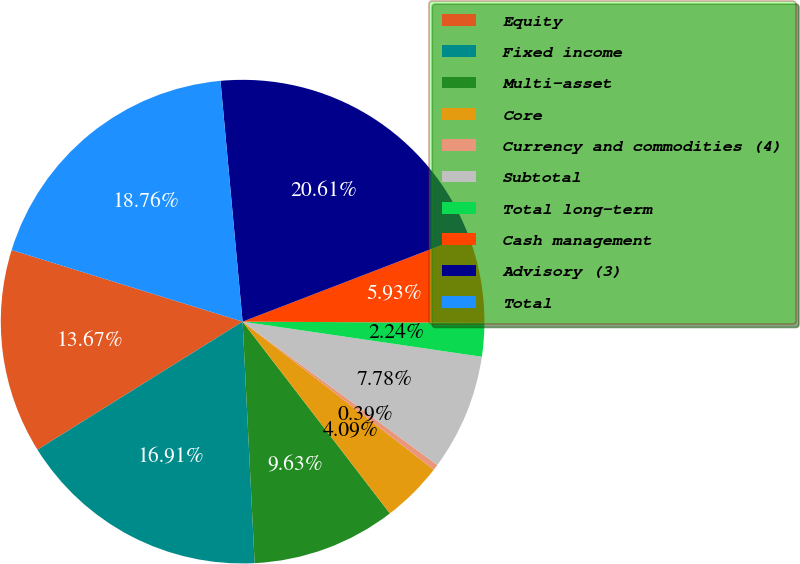Convert chart to OTSL. <chart><loc_0><loc_0><loc_500><loc_500><pie_chart><fcel>Equity<fcel>Fixed income<fcel>Multi-asset<fcel>Core<fcel>Currency and commodities (4)<fcel>Subtotal<fcel>Total long-term<fcel>Cash management<fcel>Advisory (3)<fcel>Total<nl><fcel>13.67%<fcel>16.91%<fcel>9.63%<fcel>4.09%<fcel>0.39%<fcel>7.78%<fcel>2.24%<fcel>5.93%<fcel>20.61%<fcel>18.76%<nl></chart> 